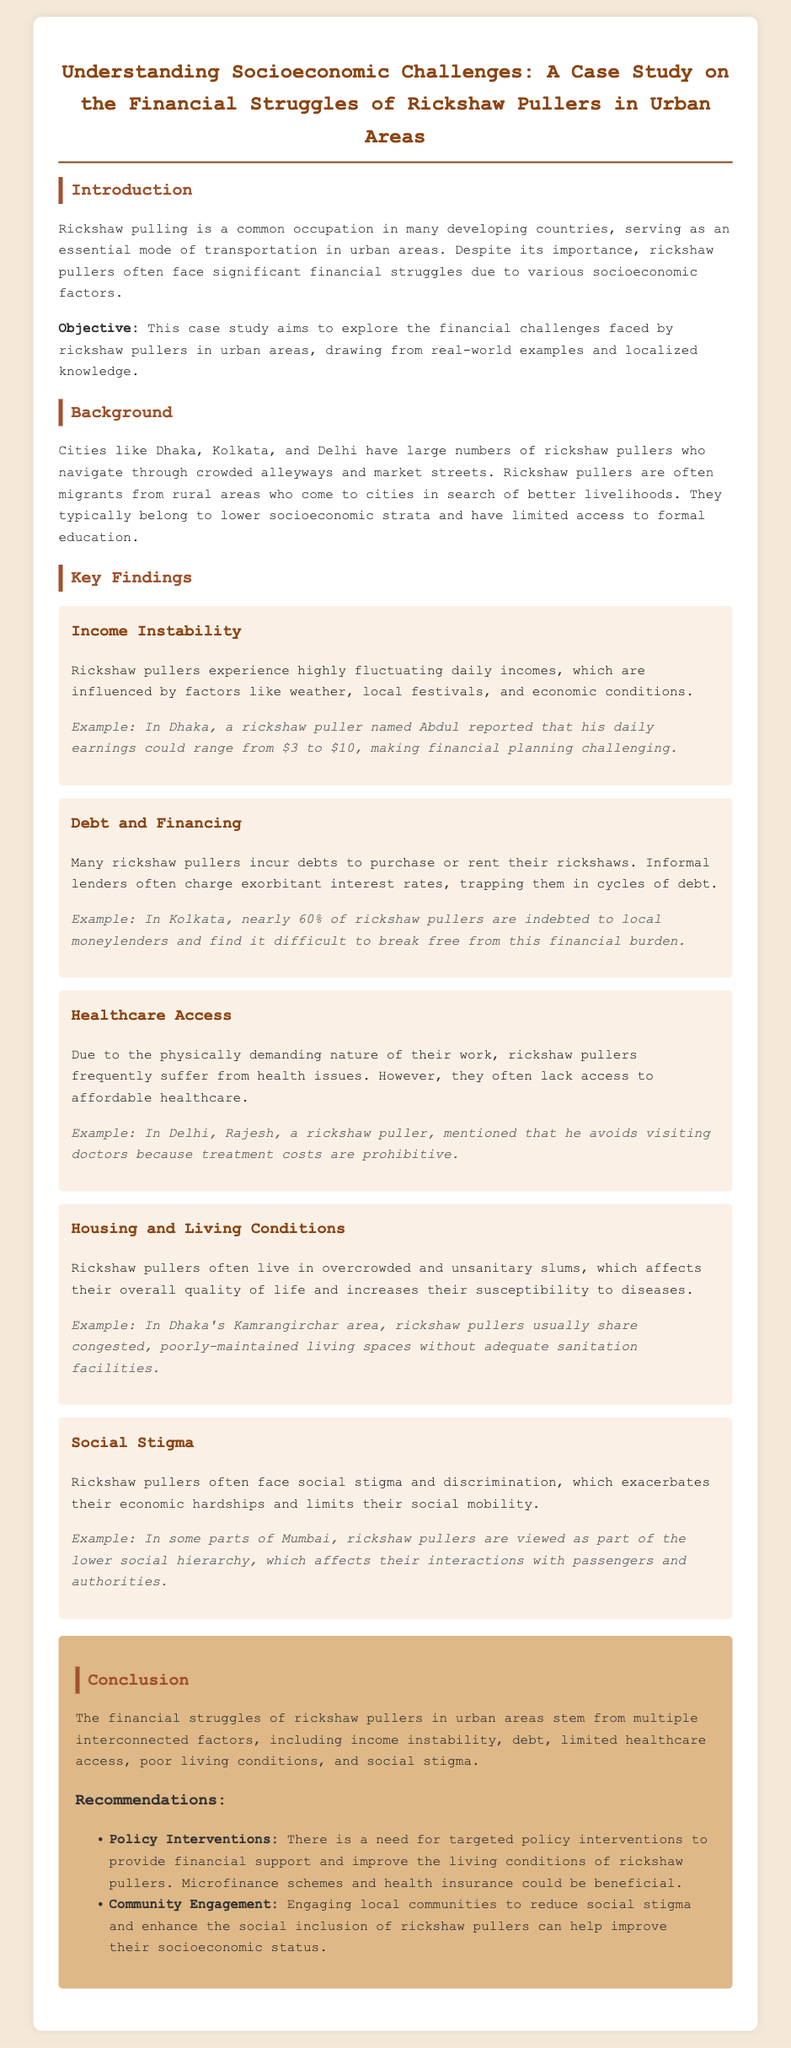what is the title of the case study? The title is the heading of the document which summarizes the focus on rickshaw pullers and their financial struggles.
Answer: Understanding Socioeconomic Challenges: A Case Study on the Financial Struggles of Rickshaw Pullers in Urban Areas how much can a rickshaw puller's daily earnings range from in Dhaka? This information is provided in the income instability section describing the financial variability faced by rickshaw pullers.
Answer: $3 to $10 what percentage of rickshaw pullers in Kolkata are indebted to local moneylenders? This statistic is mentioned in the debt and financing section highlighting the financial burden on rickshaw pullers.
Answer: 60% what is one example of a health issue faced by rickshaw pullers? The healthcare access section discusses the physical demands of the job leading to certain health issues.
Answer: Health issues which area in Dhaka is mentioned in relation to rickshaw pullers' living conditions? The background section specifies a certain area tied to overcrowding and poor sanitation faced by rickshaw pullers.
Answer: Kamrangirchar what do policy interventions aim to provide for rickshaw pullers? The conclusion section outlines a specific goal of the recommendations that focuses on support for rickshaw pullers.
Answer: Financial support what is a recommended approach to reduce social stigma against rickshaw pullers? The conclusion provides a recommendation on community involvement to enhance inclusion and reduce stigma.
Answer: Community Engagement 